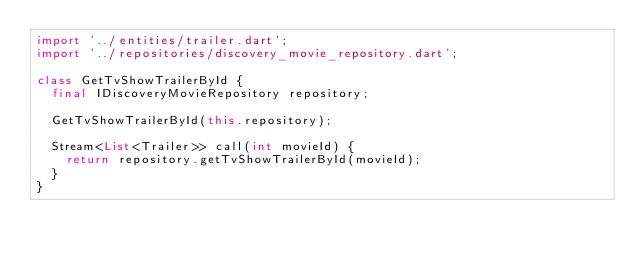Convert code to text. <code><loc_0><loc_0><loc_500><loc_500><_Dart_>import '../entities/trailer.dart';
import '../repositories/discovery_movie_repository.dart';

class GetTvShowTrailerById {
  final IDiscoveryMovieRepository repository;

  GetTvShowTrailerById(this.repository);

  Stream<List<Trailer>> call(int movieId) {
    return repository.getTvShowTrailerById(movieId);
  }
}
</code> 